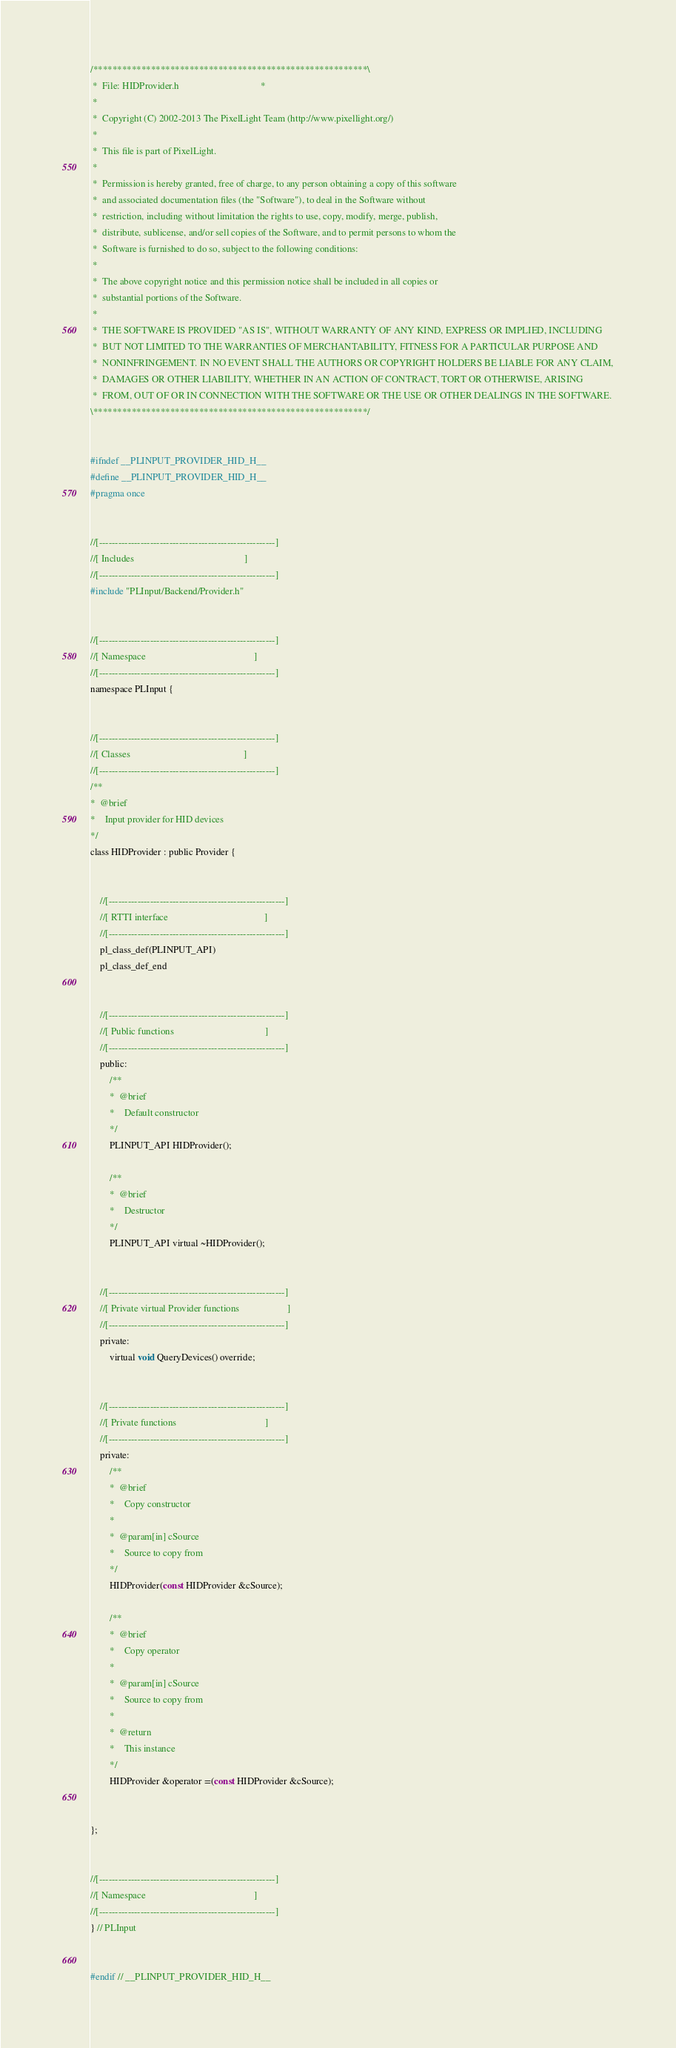<code> <loc_0><loc_0><loc_500><loc_500><_C_>/*********************************************************\
 *  File: HIDProvider.h                                  *
 *
 *  Copyright (C) 2002-2013 The PixelLight Team (http://www.pixellight.org/)
 *
 *  This file is part of PixelLight.
 *
 *  Permission is hereby granted, free of charge, to any person obtaining a copy of this software
 *  and associated documentation files (the "Software"), to deal in the Software without
 *  restriction, including without limitation the rights to use, copy, modify, merge, publish,
 *  distribute, sublicense, and/or sell copies of the Software, and to permit persons to whom the
 *  Software is furnished to do so, subject to the following conditions:
 *
 *  The above copyright notice and this permission notice shall be included in all copies or
 *  substantial portions of the Software.
 *
 *  THE SOFTWARE IS PROVIDED "AS IS", WITHOUT WARRANTY OF ANY KIND, EXPRESS OR IMPLIED, INCLUDING
 *  BUT NOT LIMITED TO THE WARRANTIES OF MERCHANTABILITY, FITNESS FOR A PARTICULAR PURPOSE AND
 *  NONINFRINGEMENT. IN NO EVENT SHALL THE AUTHORS OR COPYRIGHT HOLDERS BE LIABLE FOR ANY CLAIM,
 *  DAMAGES OR OTHER LIABILITY, WHETHER IN AN ACTION OF CONTRACT, TORT OR OTHERWISE, ARISING
 *  FROM, OUT OF OR IN CONNECTION WITH THE SOFTWARE OR THE USE OR OTHER DEALINGS IN THE SOFTWARE.
\*********************************************************/


#ifndef __PLINPUT_PROVIDER_HID_H__
#define __PLINPUT_PROVIDER_HID_H__
#pragma once


//[-------------------------------------------------------]
//[ Includes                                              ]
//[-------------------------------------------------------]
#include "PLInput/Backend/Provider.h"


//[-------------------------------------------------------]
//[ Namespace                                             ]
//[-------------------------------------------------------]
namespace PLInput {


//[-------------------------------------------------------]
//[ Classes                                               ]
//[-------------------------------------------------------]
/**
*  @brief
*    Input provider for HID devices
*/
class HIDProvider : public Provider {


	//[-------------------------------------------------------]
	//[ RTTI interface                                        ]
	//[-------------------------------------------------------]
	pl_class_def(PLINPUT_API)
	pl_class_def_end


	//[-------------------------------------------------------]
	//[ Public functions                                      ]
	//[-------------------------------------------------------]
	public:
		/**
		*  @brief
		*    Default constructor
		*/
		PLINPUT_API HIDProvider();

		/**
		*  @brief
		*    Destructor
		*/
		PLINPUT_API virtual ~HIDProvider();


	//[-------------------------------------------------------]
	//[ Private virtual Provider functions                    ]
	//[-------------------------------------------------------]
	private:
		virtual void QueryDevices() override;


	//[-------------------------------------------------------]
	//[ Private functions                                     ]
	//[-------------------------------------------------------]
	private:
		/**
		*  @brief
		*    Copy constructor
		*
		*  @param[in] cSource
		*    Source to copy from
		*/
		HIDProvider(const HIDProvider &cSource);

		/**
		*  @brief
		*    Copy operator
		*
		*  @param[in] cSource
		*    Source to copy from
		*
		*  @return
		*    This instance
		*/
		HIDProvider &operator =(const HIDProvider &cSource);


};


//[-------------------------------------------------------]
//[ Namespace                                             ]
//[-------------------------------------------------------]
} // PLInput


#endif // __PLINPUT_PROVIDER_HID_H__
</code> 